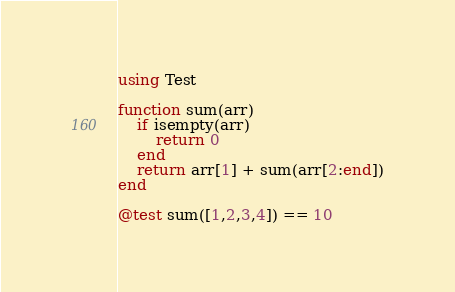Convert code to text. <code><loc_0><loc_0><loc_500><loc_500><_Julia_>using Test

function sum(arr)
    if isempty(arr)
        return 0
    end
    return arr[1] + sum(arr[2:end])
end

@test sum([1,2,3,4]) == 10
</code> 